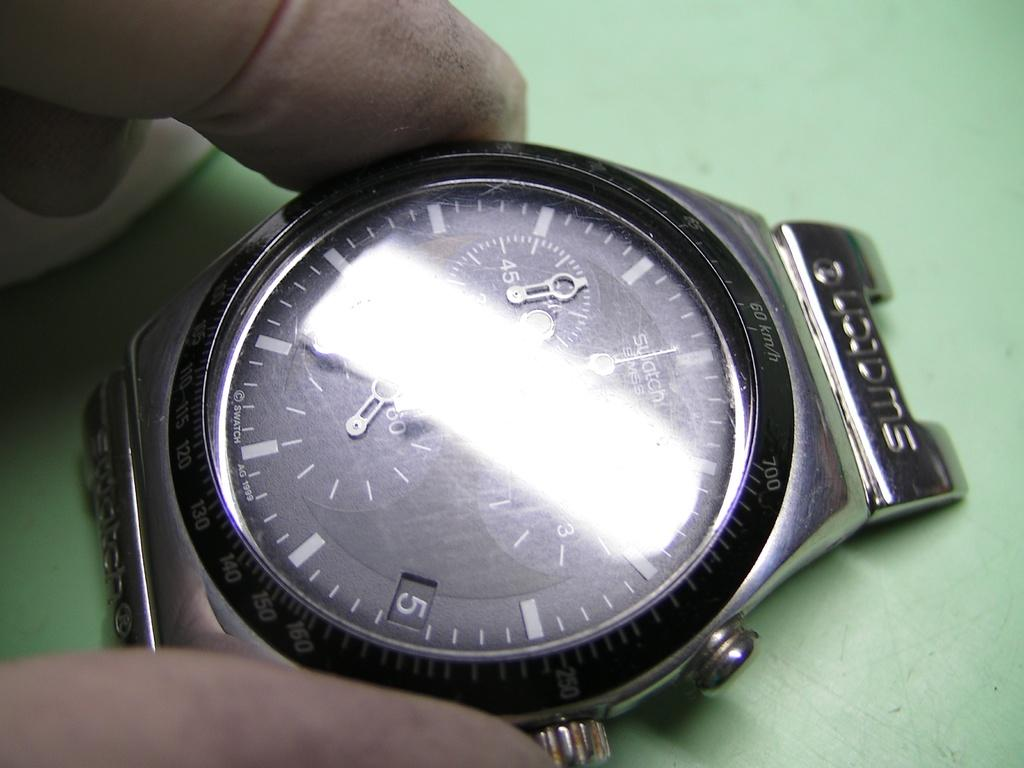<image>
Provide a brief description of the given image. A close up of a watch that says Swiss Swatch on it. 